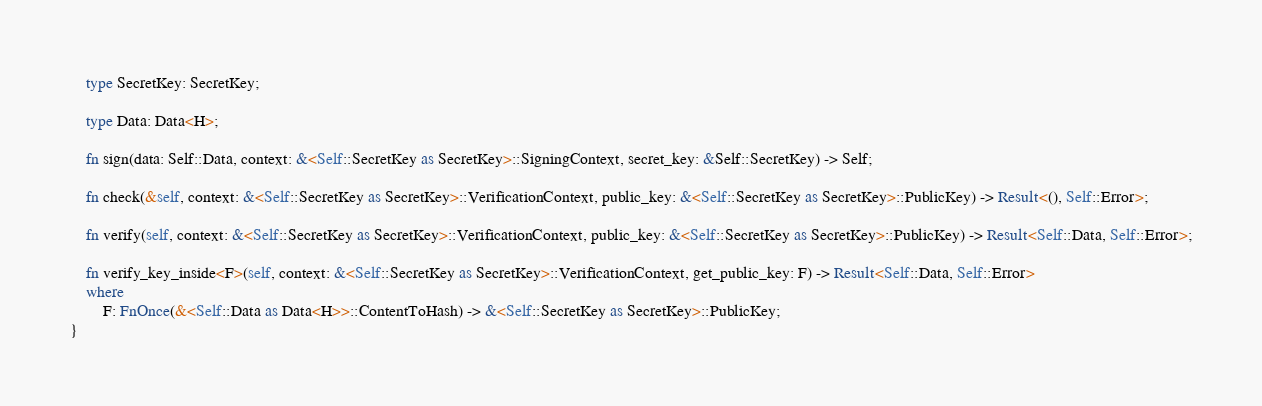<code> <loc_0><loc_0><loc_500><loc_500><_Rust_>
    type SecretKey: SecretKey;

    type Data: Data<H>;

    fn sign(data: Self::Data, context: &<Self::SecretKey as SecretKey>::SigningContext, secret_key: &Self::SecretKey) -> Self;

    fn check(&self, context: &<Self::SecretKey as SecretKey>::VerificationContext, public_key: &<Self::SecretKey as SecretKey>::PublicKey) -> Result<(), Self::Error>;

    fn verify(self, context: &<Self::SecretKey as SecretKey>::VerificationContext, public_key: &<Self::SecretKey as SecretKey>::PublicKey) -> Result<Self::Data, Self::Error>;

    fn verify_key_inside<F>(self, context: &<Self::SecretKey as SecretKey>::VerificationContext, get_public_key: F) -> Result<Self::Data, Self::Error>
    where
        F: FnOnce(&<Self::Data as Data<H>>::ContentToHash) -> &<Self::SecretKey as SecretKey>::PublicKey;
}
</code> 